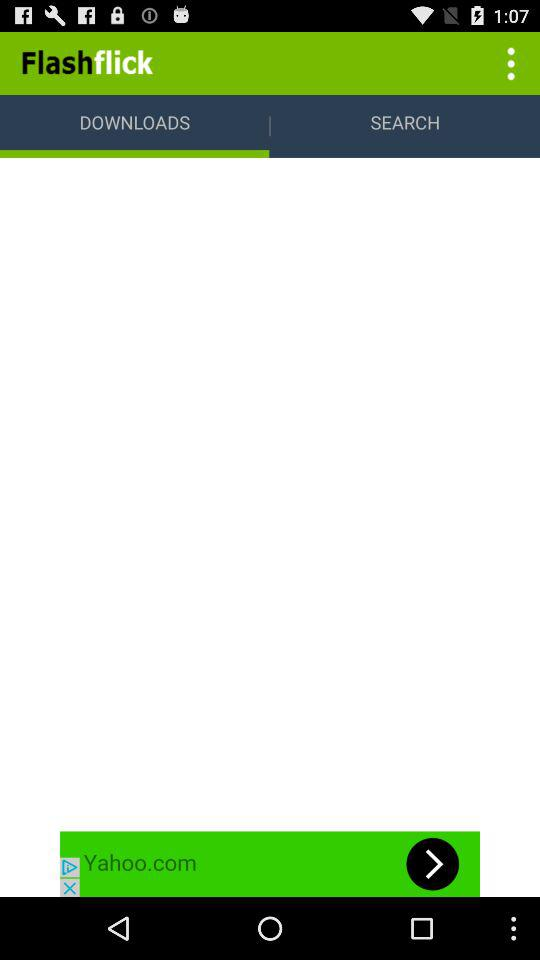What is the selected tab? The selected tab is "DOWNLOADS". 